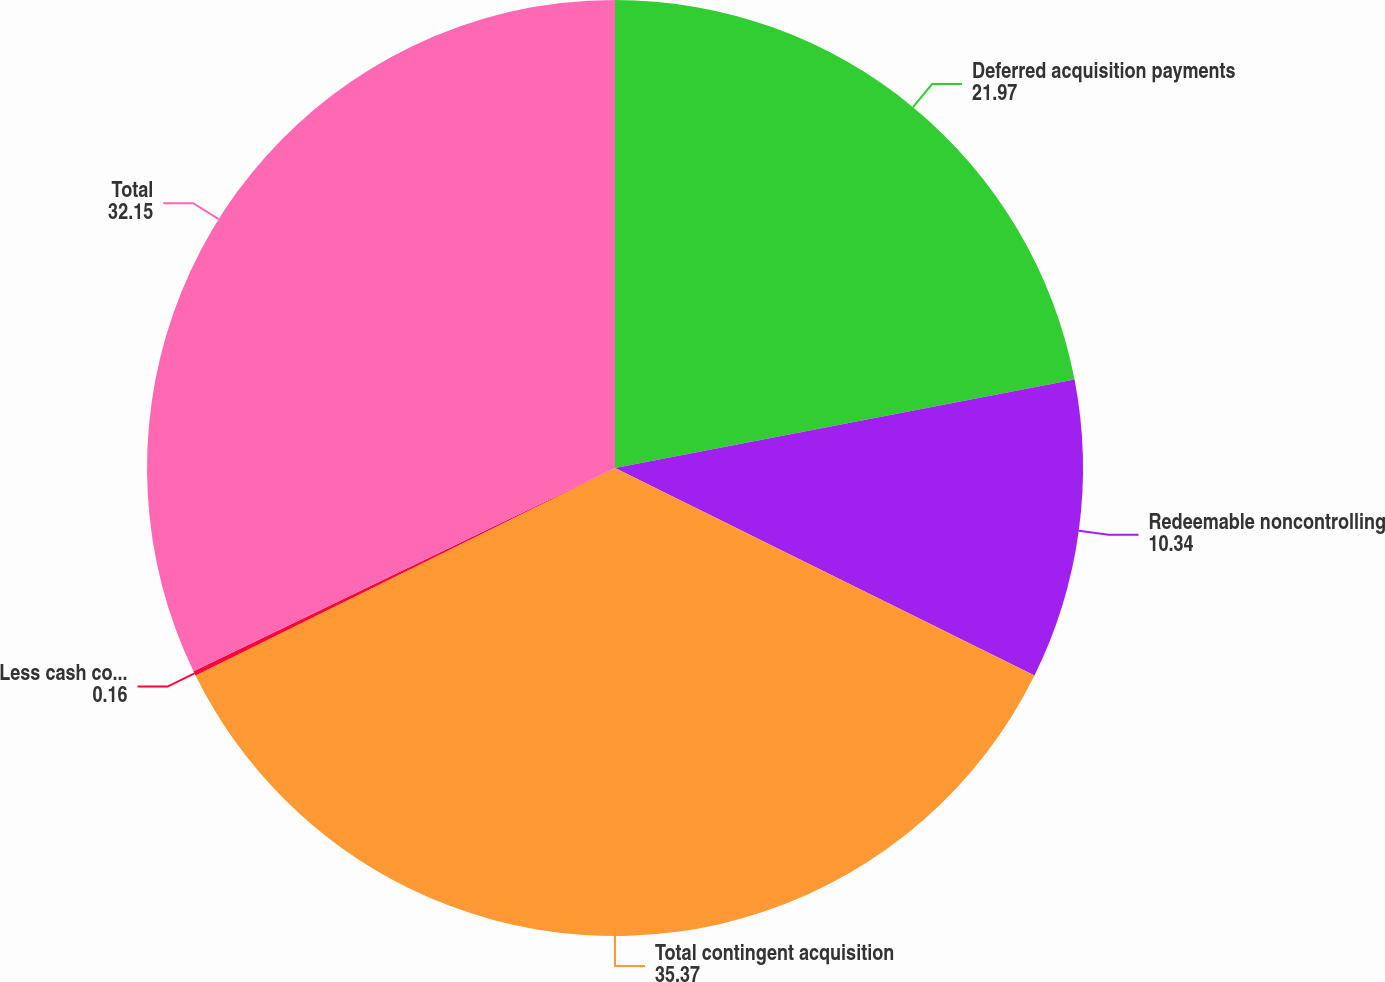Convert chart to OTSL. <chart><loc_0><loc_0><loc_500><loc_500><pie_chart><fcel>Deferred acquisition payments<fcel>Redeemable noncontrolling<fcel>Total contingent acquisition<fcel>Less cash compensation expense<fcel>Total<nl><fcel>21.97%<fcel>10.34%<fcel>35.37%<fcel>0.16%<fcel>32.15%<nl></chart> 